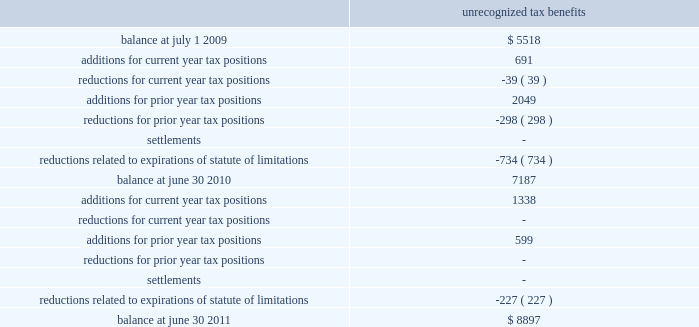Fy 11 | 53 the company paid income taxes of $ 60515 , $ 42116 , and $ 62965 in 2011 , 2010 , and 2009 , respectively .
At june 30 , 2010 , the company had $ 7187 of unrecognized tax benefits .
At june 30 , 2011 , the company had $ 8897 of unrecognized tax benefits , of which , $ 6655 , if recognized , would affect our effective tax rate .
We had accrued interest and penalties of $ 1030 and $ 890 related to uncertain tax positions at june 30 , 2011 and 2010 , respectively .
A reconciliation of the unrecognized tax benefits for the years ended june 30 , 2011 and 2010 follows : unrecognized tax benefits .
During the fiscal year ended june 30 , 2010 , the internal revenue service commenced an examination of the company 2019s u.s .
Federal income tax returns for fiscal years ended june 2008 through 2009 that is anticipated to be completed by the end of calendar year 2011 .
At this time , it is anticipated that the examination will not result in a material change to the company 2019s financial position .
The u.s .
Federal and state income tax returns for june 30 , 2008 and all subsequent years still remain subject to examination as of june 30 , 2011 under statute of limitations rules .
We anticipate potential changes resulting from our irs examination and expiration of statutes of limitations could reduce the unrecognized tax benefits balance by $ 3000 - $ 4000 within twelve months of june 30 , 2011 .
Note 8 : industry and supplier concentrations the company sells its products to banks , credit unions , and financial institutions throughout the united states and generally does not require collateral .
All billings to customers are due 30 days from date of billing .
Reserves ( which are insignificant at june 30 , 2011 , 2010 and 2009 ) are maintained for potential credit losses .
In addition , the company purchases most of its computer hardware and related maintenance for resale in relation to installation of jha software systems from two suppliers .
There are a limited number of hardware suppliers for these required items .
If these relationships were terminated , it could have a significant negative impact on the future operations of the company .
Note 9 : stock based compensation plans our pre-tax operating income for the years ended june 30 , 2011 , 2010 and 2009 includes $ 4723 , $ 3251 and $ 2272 of stock-based compensation costs , respectively .
Total compensation cost for the years ended june 30 , 2011 , 2010 and 2009 includes $ 4209 , $ 2347 , and $ 1620 relating to the restricted stock plan , respectively. .
If the maximum projected change to unrecognized tax benefits from the irs examination does occur , what would the new balance be june 30 , 2011? 
Computations: (8897 - 4000)
Answer: 4897.0. 